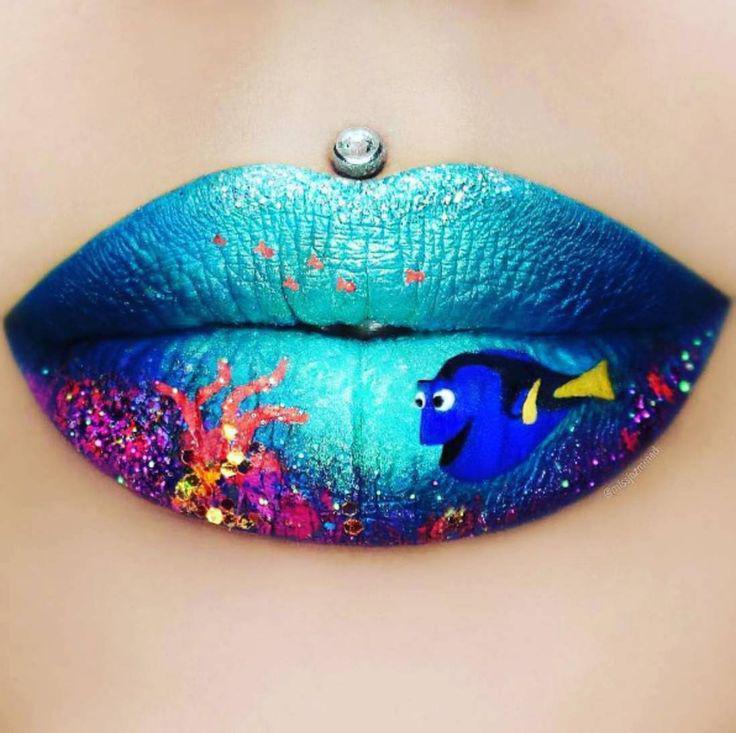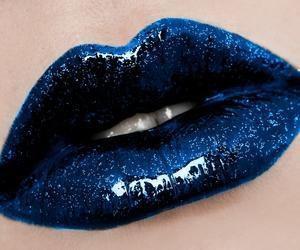The first image is the image on the left, the second image is the image on the right. Given the left and right images, does the statement "A single rhinestone stud is directly above a pair of glittery lips in one image." hold true? Answer yes or no. Yes. The first image is the image on the left, the second image is the image on the right. For the images shown, is this caption "One of the lips has a piercing directly above the upper lip that is not attached to the nose." true? Answer yes or no. Yes. 